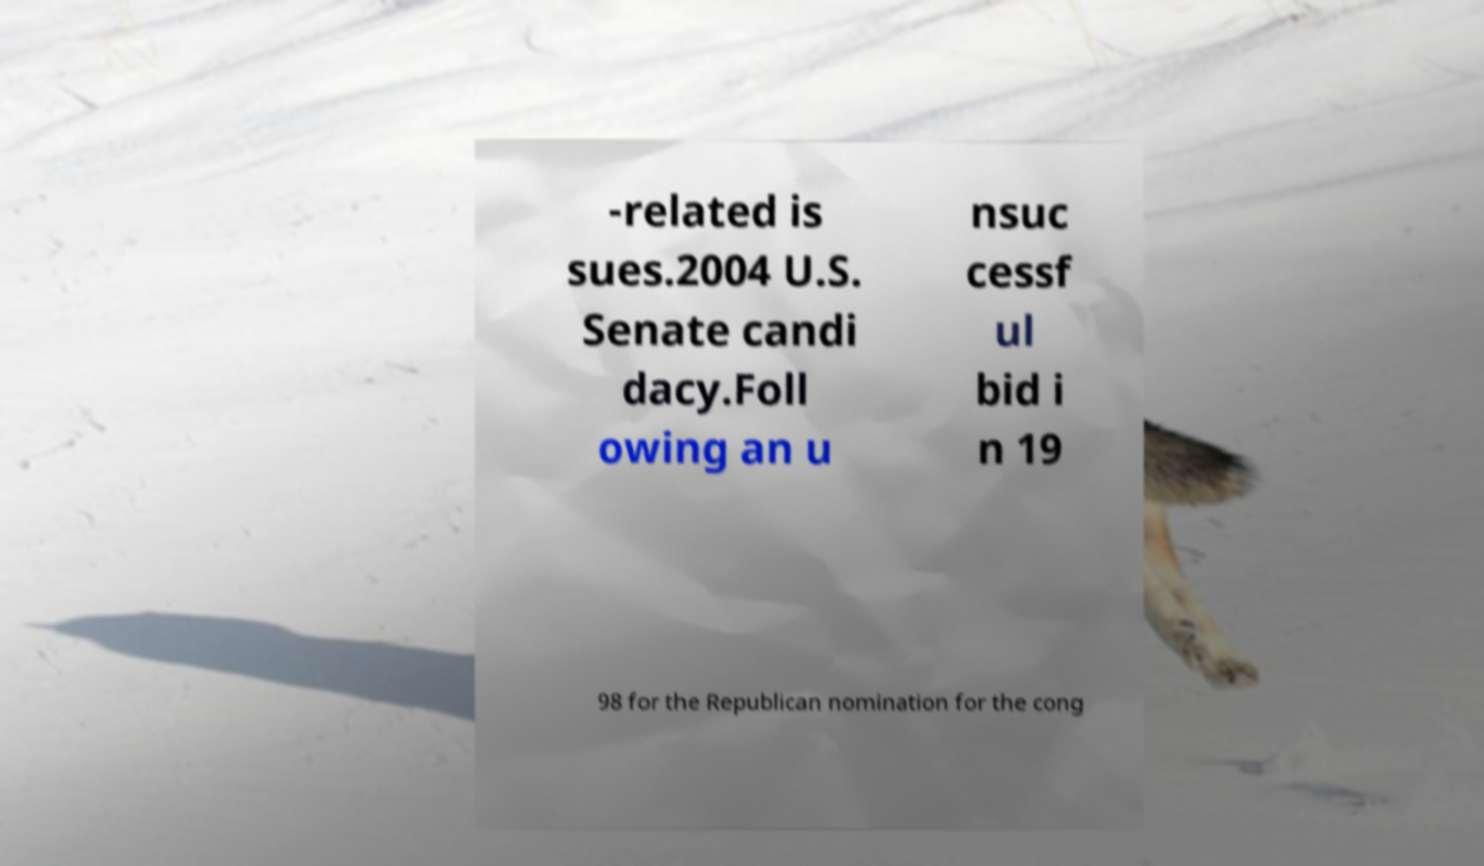For documentation purposes, I need the text within this image transcribed. Could you provide that? -related is sues.2004 U.S. Senate candi dacy.Foll owing an u nsuc cessf ul bid i n 19 98 for the Republican nomination for the cong 